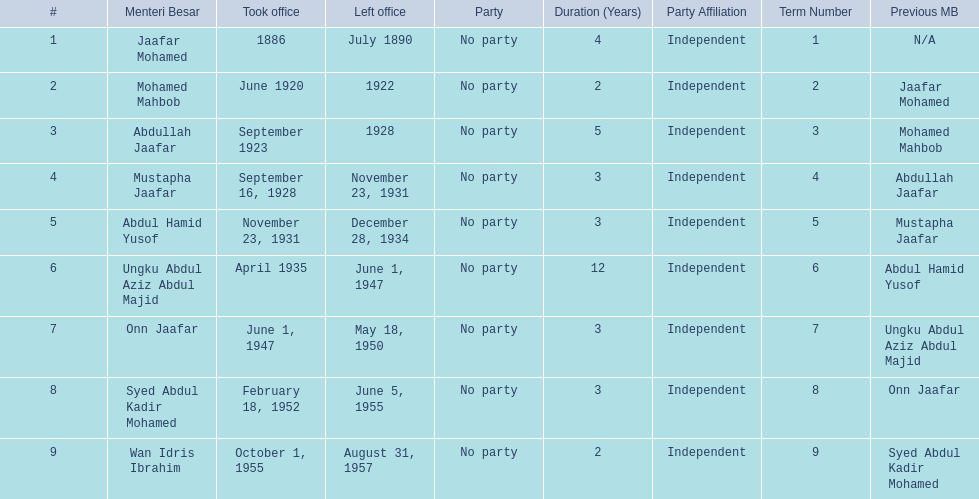Who spend the most amount of time in office? Ungku Abdul Aziz Abdul Majid. 